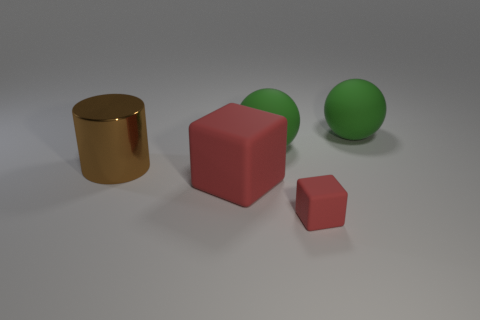Is there any other thing that has the same size as the metal cylinder?
Offer a terse response. Yes. There is a big block that is the same color as the tiny rubber cube; what is it made of?
Provide a short and direct response. Rubber. What number of large red rubber things have the same shape as the tiny red thing?
Keep it short and to the point. 1. Is the small cube the same color as the big rubber block?
Give a very brief answer. Yes. Are there fewer matte spheres than small gray metal blocks?
Provide a short and direct response. No. There is a red block that is right of the large red object; what is its material?
Your response must be concise. Rubber. What material is the red block that is the same size as the brown metal cylinder?
Your answer should be compact. Rubber. What is the material of the ball that is in front of the green ball that is on the right side of the red thing right of the big red rubber block?
Offer a very short reply. Rubber. Are there more red blocks than small yellow rubber balls?
Provide a succinct answer. Yes. What number of small things are brown things or green shiny things?
Your response must be concise. 0. 